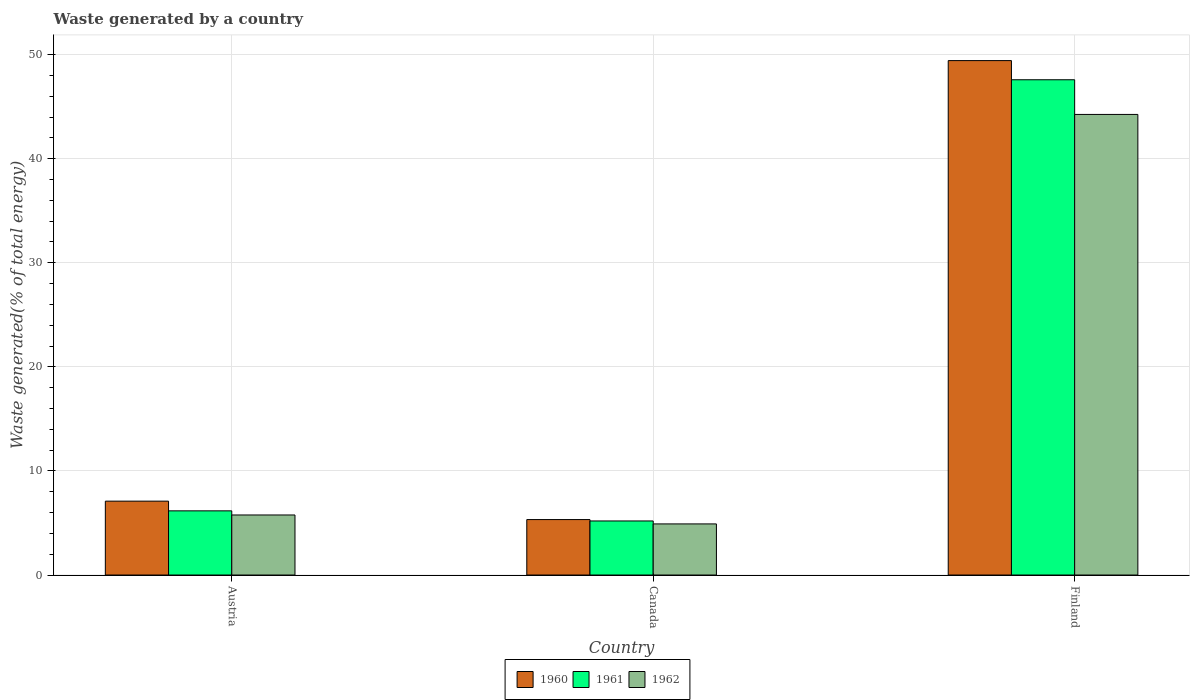How many different coloured bars are there?
Provide a succinct answer. 3. How many groups of bars are there?
Offer a very short reply. 3. Are the number of bars on each tick of the X-axis equal?
Give a very brief answer. Yes. How many bars are there on the 3rd tick from the left?
Your answer should be compact. 3. How many bars are there on the 2nd tick from the right?
Ensure brevity in your answer.  3. What is the label of the 1st group of bars from the left?
Offer a very short reply. Austria. What is the total waste generated in 1960 in Austria?
Offer a terse response. 7.1. Across all countries, what is the maximum total waste generated in 1962?
Provide a succinct answer. 44.25. Across all countries, what is the minimum total waste generated in 1961?
Your response must be concise. 5.19. In which country was the total waste generated in 1962 minimum?
Provide a short and direct response. Canada. What is the total total waste generated in 1961 in the graph?
Ensure brevity in your answer.  58.94. What is the difference between the total waste generated in 1962 in Canada and that in Finland?
Keep it short and to the point. -39.34. What is the difference between the total waste generated in 1960 in Canada and the total waste generated in 1962 in Finland?
Offer a very short reply. -38.92. What is the average total waste generated in 1962 per country?
Give a very brief answer. 18.31. What is the difference between the total waste generated of/in 1961 and total waste generated of/in 1960 in Canada?
Provide a succinct answer. -0.13. What is the ratio of the total waste generated in 1960 in Austria to that in Finland?
Provide a short and direct response. 0.14. Is the total waste generated in 1961 in Austria less than that in Finland?
Provide a succinct answer. Yes. What is the difference between the highest and the second highest total waste generated in 1961?
Your response must be concise. -0.97. What is the difference between the highest and the lowest total waste generated in 1961?
Give a very brief answer. 42.39. What does the 2nd bar from the right in Canada represents?
Provide a succinct answer. 1961. Is it the case that in every country, the sum of the total waste generated in 1961 and total waste generated in 1960 is greater than the total waste generated in 1962?
Your answer should be very brief. Yes. How many bars are there?
Make the answer very short. 9. How many countries are there in the graph?
Your answer should be very brief. 3. Does the graph contain any zero values?
Offer a terse response. No. Does the graph contain grids?
Offer a very short reply. Yes. Where does the legend appear in the graph?
Keep it short and to the point. Bottom center. How are the legend labels stacked?
Your response must be concise. Horizontal. What is the title of the graph?
Provide a short and direct response. Waste generated by a country. Does "1972" appear as one of the legend labels in the graph?
Your answer should be very brief. No. What is the label or title of the Y-axis?
Make the answer very short. Waste generated(% of total energy). What is the Waste generated(% of total energy) in 1960 in Austria?
Offer a very short reply. 7.1. What is the Waste generated(% of total energy) in 1961 in Austria?
Ensure brevity in your answer.  6.16. What is the Waste generated(% of total energy) in 1962 in Austria?
Your response must be concise. 5.77. What is the Waste generated(% of total energy) in 1960 in Canada?
Offer a terse response. 5.33. What is the Waste generated(% of total energy) in 1961 in Canada?
Ensure brevity in your answer.  5.19. What is the Waste generated(% of total energy) of 1962 in Canada?
Give a very brief answer. 4.91. What is the Waste generated(% of total energy) in 1960 in Finland?
Provide a succinct answer. 49.42. What is the Waste generated(% of total energy) in 1961 in Finland?
Provide a succinct answer. 47.58. What is the Waste generated(% of total energy) of 1962 in Finland?
Offer a terse response. 44.25. Across all countries, what is the maximum Waste generated(% of total energy) of 1960?
Ensure brevity in your answer.  49.42. Across all countries, what is the maximum Waste generated(% of total energy) of 1961?
Give a very brief answer. 47.58. Across all countries, what is the maximum Waste generated(% of total energy) of 1962?
Keep it short and to the point. 44.25. Across all countries, what is the minimum Waste generated(% of total energy) in 1960?
Your answer should be compact. 5.33. Across all countries, what is the minimum Waste generated(% of total energy) of 1961?
Offer a very short reply. 5.19. Across all countries, what is the minimum Waste generated(% of total energy) in 1962?
Provide a short and direct response. 4.91. What is the total Waste generated(% of total energy) in 1960 in the graph?
Give a very brief answer. 61.85. What is the total Waste generated(% of total energy) in 1961 in the graph?
Keep it short and to the point. 58.94. What is the total Waste generated(% of total energy) in 1962 in the graph?
Provide a short and direct response. 54.93. What is the difference between the Waste generated(% of total energy) of 1960 in Austria and that in Canada?
Your answer should be very brief. 1.77. What is the difference between the Waste generated(% of total energy) of 1961 in Austria and that in Canada?
Your response must be concise. 0.97. What is the difference between the Waste generated(% of total energy) in 1962 in Austria and that in Canada?
Your answer should be compact. 0.86. What is the difference between the Waste generated(% of total energy) of 1960 in Austria and that in Finland?
Give a very brief answer. -42.33. What is the difference between the Waste generated(% of total energy) in 1961 in Austria and that in Finland?
Provide a short and direct response. -41.42. What is the difference between the Waste generated(% of total energy) of 1962 in Austria and that in Finland?
Keep it short and to the point. -38.48. What is the difference between the Waste generated(% of total energy) of 1960 in Canada and that in Finland?
Your response must be concise. -44.1. What is the difference between the Waste generated(% of total energy) of 1961 in Canada and that in Finland?
Keep it short and to the point. -42.39. What is the difference between the Waste generated(% of total energy) in 1962 in Canada and that in Finland?
Give a very brief answer. -39.34. What is the difference between the Waste generated(% of total energy) in 1960 in Austria and the Waste generated(% of total energy) in 1961 in Canada?
Ensure brevity in your answer.  1.9. What is the difference between the Waste generated(% of total energy) of 1960 in Austria and the Waste generated(% of total energy) of 1962 in Canada?
Your answer should be compact. 2.19. What is the difference between the Waste generated(% of total energy) of 1961 in Austria and the Waste generated(% of total energy) of 1962 in Canada?
Your response must be concise. 1.25. What is the difference between the Waste generated(% of total energy) in 1960 in Austria and the Waste generated(% of total energy) in 1961 in Finland?
Your answer should be very brief. -40.48. What is the difference between the Waste generated(% of total energy) in 1960 in Austria and the Waste generated(% of total energy) in 1962 in Finland?
Give a very brief answer. -37.15. What is the difference between the Waste generated(% of total energy) of 1961 in Austria and the Waste generated(% of total energy) of 1962 in Finland?
Your response must be concise. -38.09. What is the difference between the Waste generated(% of total energy) of 1960 in Canada and the Waste generated(% of total energy) of 1961 in Finland?
Keep it short and to the point. -42.25. What is the difference between the Waste generated(% of total energy) in 1960 in Canada and the Waste generated(% of total energy) in 1962 in Finland?
Offer a very short reply. -38.92. What is the difference between the Waste generated(% of total energy) of 1961 in Canada and the Waste generated(% of total energy) of 1962 in Finland?
Your answer should be compact. -39.06. What is the average Waste generated(% of total energy) of 1960 per country?
Keep it short and to the point. 20.62. What is the average Waste generated(% of total energy) in 1961 per country?
Provide a short and direct response. 19.65. What is the average Waste generated(% of total energy) in 1962 per country?
Give a very brief answer. 18.31. What is the difference between the Waste generated(% of total energy) of 1960 and Waste generated(% of total energy) of 1961 in Austria?
Offer a terse response. 0.93. What is the difference between the Waste generated(% of total energy) in 1960 and Waste generated(% of total energy) in 1962 in Austria?
Your answer should be compact. 1.33. What is the difference between the Waste generated(% of total energy) in 1961 and Waste generated(% of total energy) in 1962 in Austria?
Offer a very short reply. 0.4. What is the difference between the Waste generated(% of total energy) in 1960 and Waste generated(% of total energy) in 1961 in Canada?
Offer a terse response. 0.13. What is the difference between the Waste generated(% of total energy) in 1960 and Waste generated(% of total energy) in 1962 in Canada?
Ensure brevity in your answer.  0.42. What is the difference between the Waste generated(% of total energy) in 1961 and Waste generated(% of total energy) in 1962 in Canada?
Provide a short and direct response. 0.28. What is the difference between the Waste generated(% of total energy) of 1960 and Waste generated(% of total energy) of 1961 in Finland?
Give a very brief answer. 1.84. What is the difference between the Waste generated(% of total energy) of 1960 and Waste generated(% of total energy) of 1962 in Finland?
Keep it short and to the point. 5.17. What is the difference between the Waste generated(% of total energy) in 1961 and Waste generated(% of total energy) in 1962 in Finland?
Your answer should be very brief. 3.33. What is the ratio of the Waste generated(% of total energy) in 1960 in Austria to that in Canada?
Keep it short and to the point. 1.33. What is the ratio of the Waste generated(% of total energy) of 1961 in Austria to that in Canada?
Offer a very short reply. 1.19. What is the ratio of the Waste generated(% of total energy) in 1962 in Austria to that in Canada?
Offer a terse response. 1.17. What is the ratio of the Waste generated(% of total energy) in 1960 in Austria to that in Finland?
Your answer should be compact. 0.14. What is the ratio of the Waste generated(% of total energy) in 1961 in Austria to that in Finland?
Provide a short and direct response. 0.13. What is the ratio of the Waste generated(% of total energy) in 1962 in Austria to that in Finland?
Give a very brief answer. 0.13. What is the ratio of the Waste generated(% of total energy) in 1960 in Canada to that in Finland?
Provide a short and direct response. 0.11. What is the ratio of the Waste generated(% of total energy) of 1961 in Canada to that in Finland?
Offer a very short reply. 0.11. What is the ratio of the Waste generated(% of total energy) of 1962 in Canada to that in Finland?
Make the answer very short. 0.11. What is the difference between the highest and the second highest Waste generated(% of total energy) of 1960?
Offer a very short reply. 42.33. What is the difference between the highest and the second highest Waste generated(% of total energy) of 1961?
Offer a terse response. 41.42. What is the difference between the highest and the second highest Waste generated(% of total energy) of 1962?
Keep it short and to the point. 38.48. What is the difference between the highest and the lowest Waste generated(% of total energy) of 1960?
Offer a very short reply. 44.1. What is the difference between the highest and the lowest Waste generated(% of total energy) in 1961?
Keep it short and to the point. 42.39. What is the difference between the highest and the lowest Waste generated(% of total energy) in 1962?
Offer a very short reply. 39.34. 